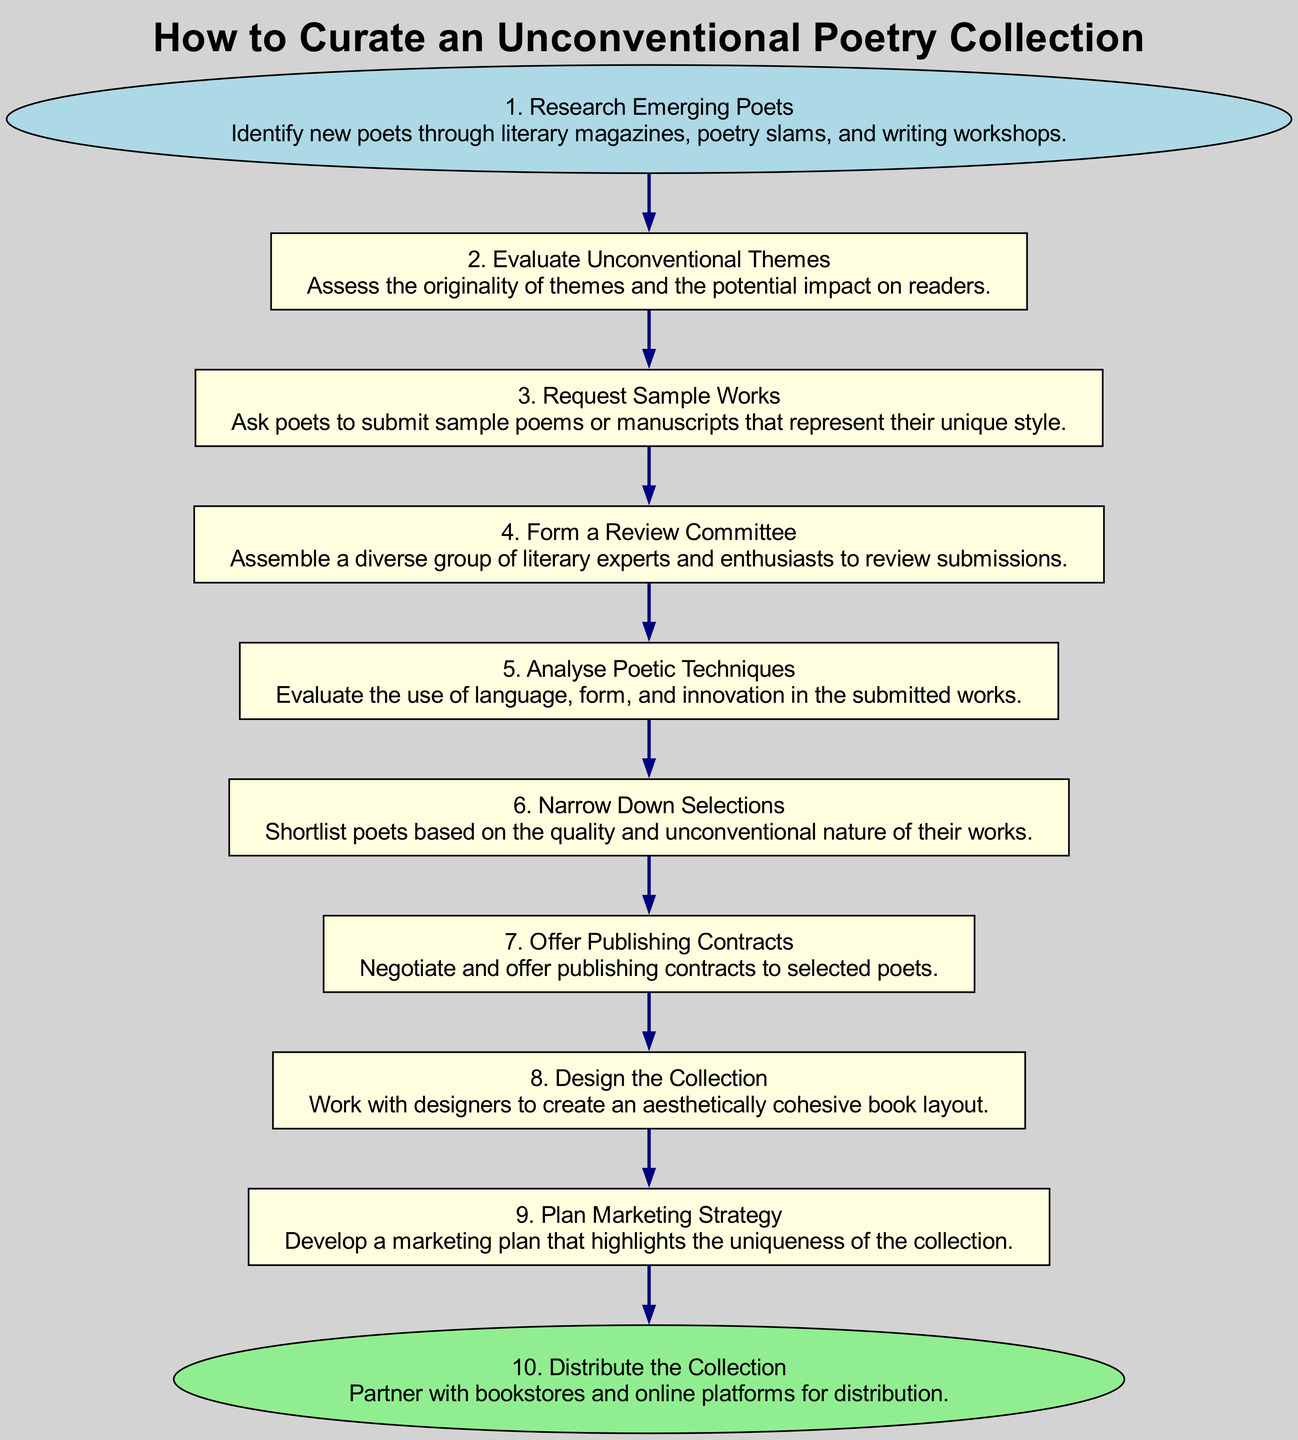What is the first step in the diagram? The first step is labeled "Research Emerging Poets," which is the starting point of the flow chart.
Answer: Research Emerging Poets How many total steps are in this flow chart? Counting each of the 10 steps listed in the diagram provides the total number of steps.
Answer: 10 What step follows "Narrow Down Selections"? By examining the flow, the next step after "Narrow Down Selections" is "Offer Publishing Contracts."
Answer: Offer Publishing Contracts Which step focuses on the uniqueness of the collection? The step titled "Plan Marketing Strategy" emphasizes developing a marketing plan that highlights the uniqueness of the collection.
Answer: Plan Marketing Strategy What is the relationship between "Evaluate Unconventional Themes" and "Request Sample Works"? "Request Sample Works" follows "Evaluate Unconventional Themes," showing that evaluating themes comes before requesting samples.
Answer: Sequential What is the last step listed in the diagram? The last step, which concludes the process, is labeled "Distribute the Collection."
Answer: Distribute the Collection Which step is specifically about analyzing poetic techniques? The step "Analyse Poetic Techniques" directly addresses the analysis of language, form, and innovation in submitted works.
Answer: Analyse Poetic Techniques How many steps are there between "Form a Review Committee" and "Design the Collection"? Counting the steps from "Form a Review Committee" (Step 4) to "Design the Collection" (Step 8), there are four steps (including the start and end).
Answer: 4 Which step involves the assembly of a diverse group? The step "Form a Review Committee" describes the action of assembling a diverse group of literary experts and enthusiasts.
Answer: Form a Review Committee 